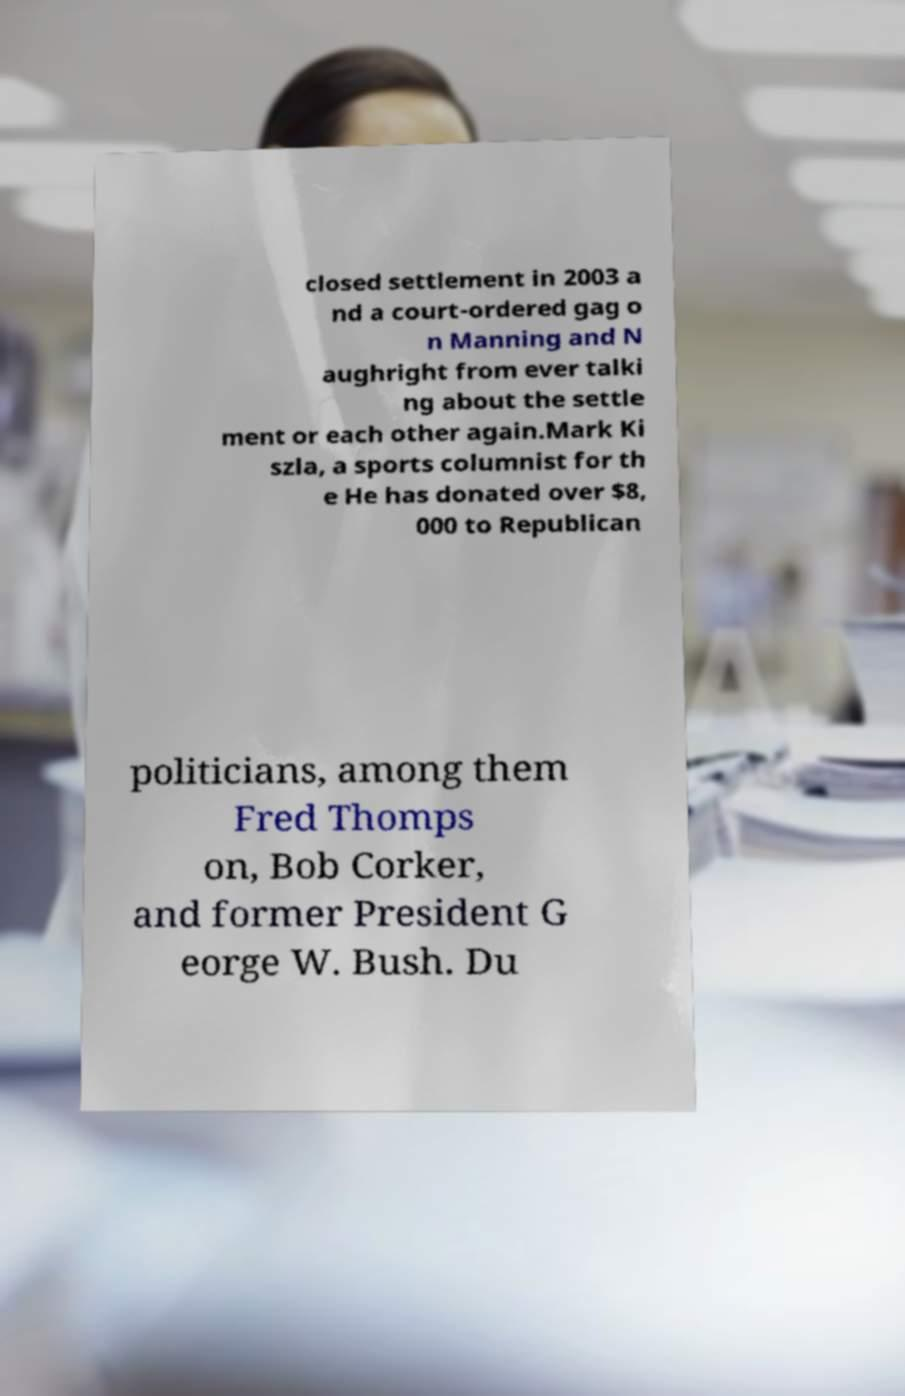Can you accurately transcribe the text from the provided image for me? closed settlement in 2003 a nd a court-ordered gag o n Manning and N aughright from ever talki ng about the settle ment or each other again.Mark Ki szla, a sports columnist for th e He has donated over $8, 000 to Republican politicians, among them Fred Thomps on, Bob Corker, and former President G eorge W. Bush. Du 